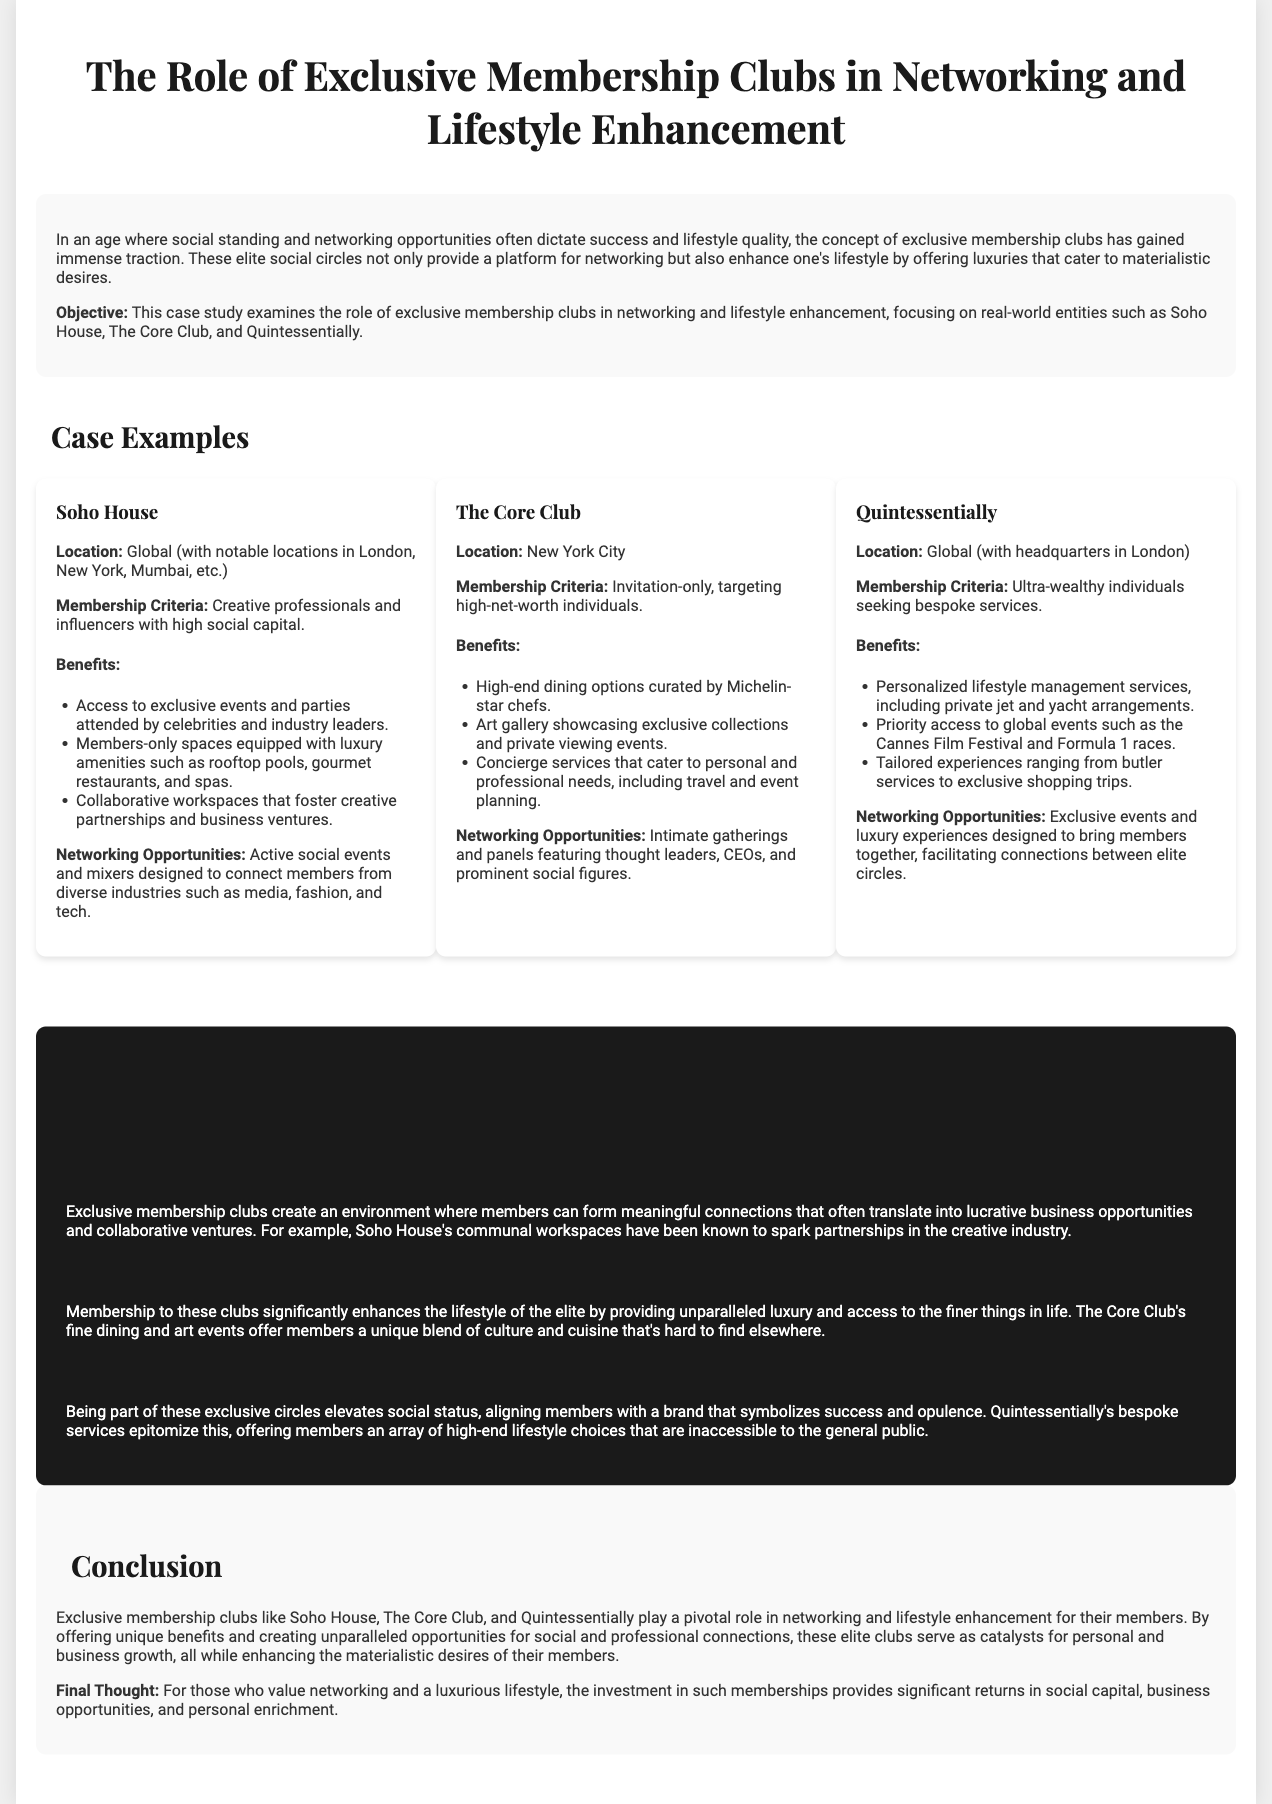What are the notable locations of Soho House? The notable locations of Soho House mentioned in the document include London, New York, and Mumbai.
Answer: London, New York, Mumbai What is the membership criterion for The Core Club? The membership criterion for The Core Club is invitation-only, targeting high-net-worth individuals.
Answer: Invitation-only What luxury service does Quintessentially offer? Quintessentially offers personalized lifestyle management services, including private jet and yacht arrangements.
Answer: Personalized lifestyle management services What enhances the lifestyle of members at exclusive clubs? Membership to these clubs enhances the lifestyle of the elite by providing unparalleled luxury and access to the finer things in life.
Answer: Unparalleled luxury What is the primary benefit of Soho House's communal workspaces? The primary benefit of Soho House's communal workspaces is to foster creative partnerships and business ventures.
Answer: Fostering creative partnerships How does membership elevate social status? Being part of these exclusive circles elevates social status by aligning members with a brand that symbolizes success and opulence.
Answer: Symbolizes success and opulence What type of events does Quintessentially provide for networking? Quintessentially provides exclusive events and luxury experiences designed to bring members together.
Answer: Exclusive events and luxury experiences What is the expected outcome of the networking opportunities provided by exclusive clubs? The expected outcome of the networking opportunities is often lucrative business opportunities and collaborative ventures.
Answer: Lucrative business opportunities What is the overall conclusion about exclusive membership clubs? The overall conclusion is that exclusive membership clubs play a pivotal role in networking and lifestyle enhancement for their members.
Answer: Pivotal role in networking and lifestyle enhancement 